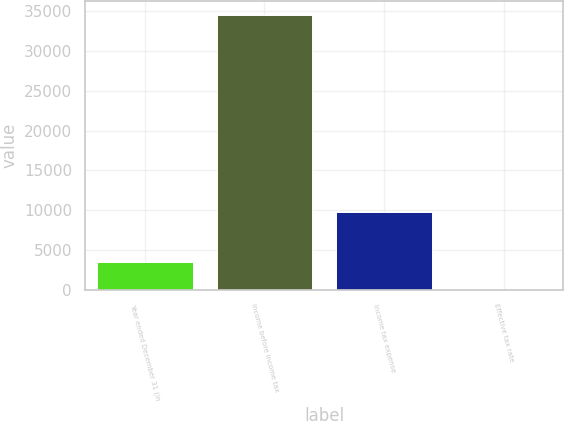Convert chart to OTSL. <chart><loc_0><loc_0><loc_500><loc_500><bar_chart><fcel>Year ended December 31 (in<fcel>Income before income tax<fcel>Income tax expense<fcel>Effective tax rate<nl><fcel>3479.16<fcel>34536<fcel>9803<fcel>28.4<nl></chart> 